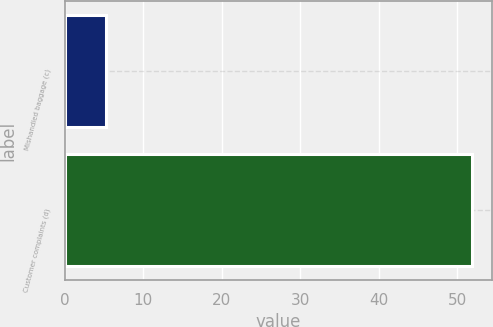Convert chart to OTSL. <chart><loc_0><loc_0><loc_500><loc_500><bar_chart><fcel>Mishandled baggage (c)<fcel>Customer complaints (d)<nl><fcel>5.3<fcel>51.9<nl></chart> 